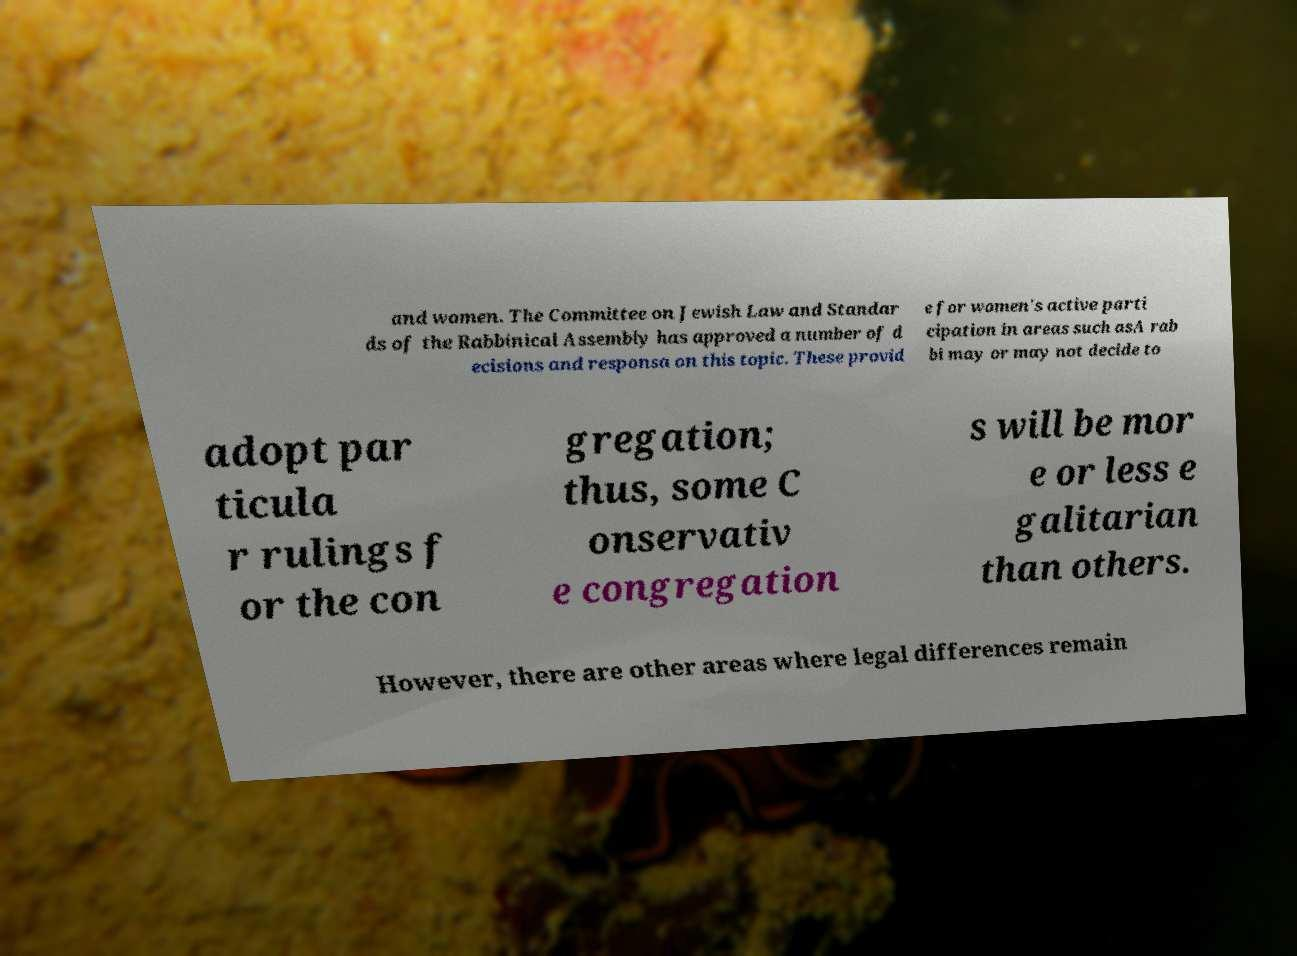For documentation purposes, I need the text within this image transcribed. Could you provide that? and women. The Committee on Jewish Law and Standar ds of the Rabbinical Assembly has approved a number of d ecisions and responsa on this topic. These provid e for women's active parti cipation in areas such asA rab bi may or may not decide to adopt par ticula r rulings f or the con gregation; thus, some C onservativ e congregation s will be mor e or less e galitarian than others. However, there are other areas where legal differences remain 